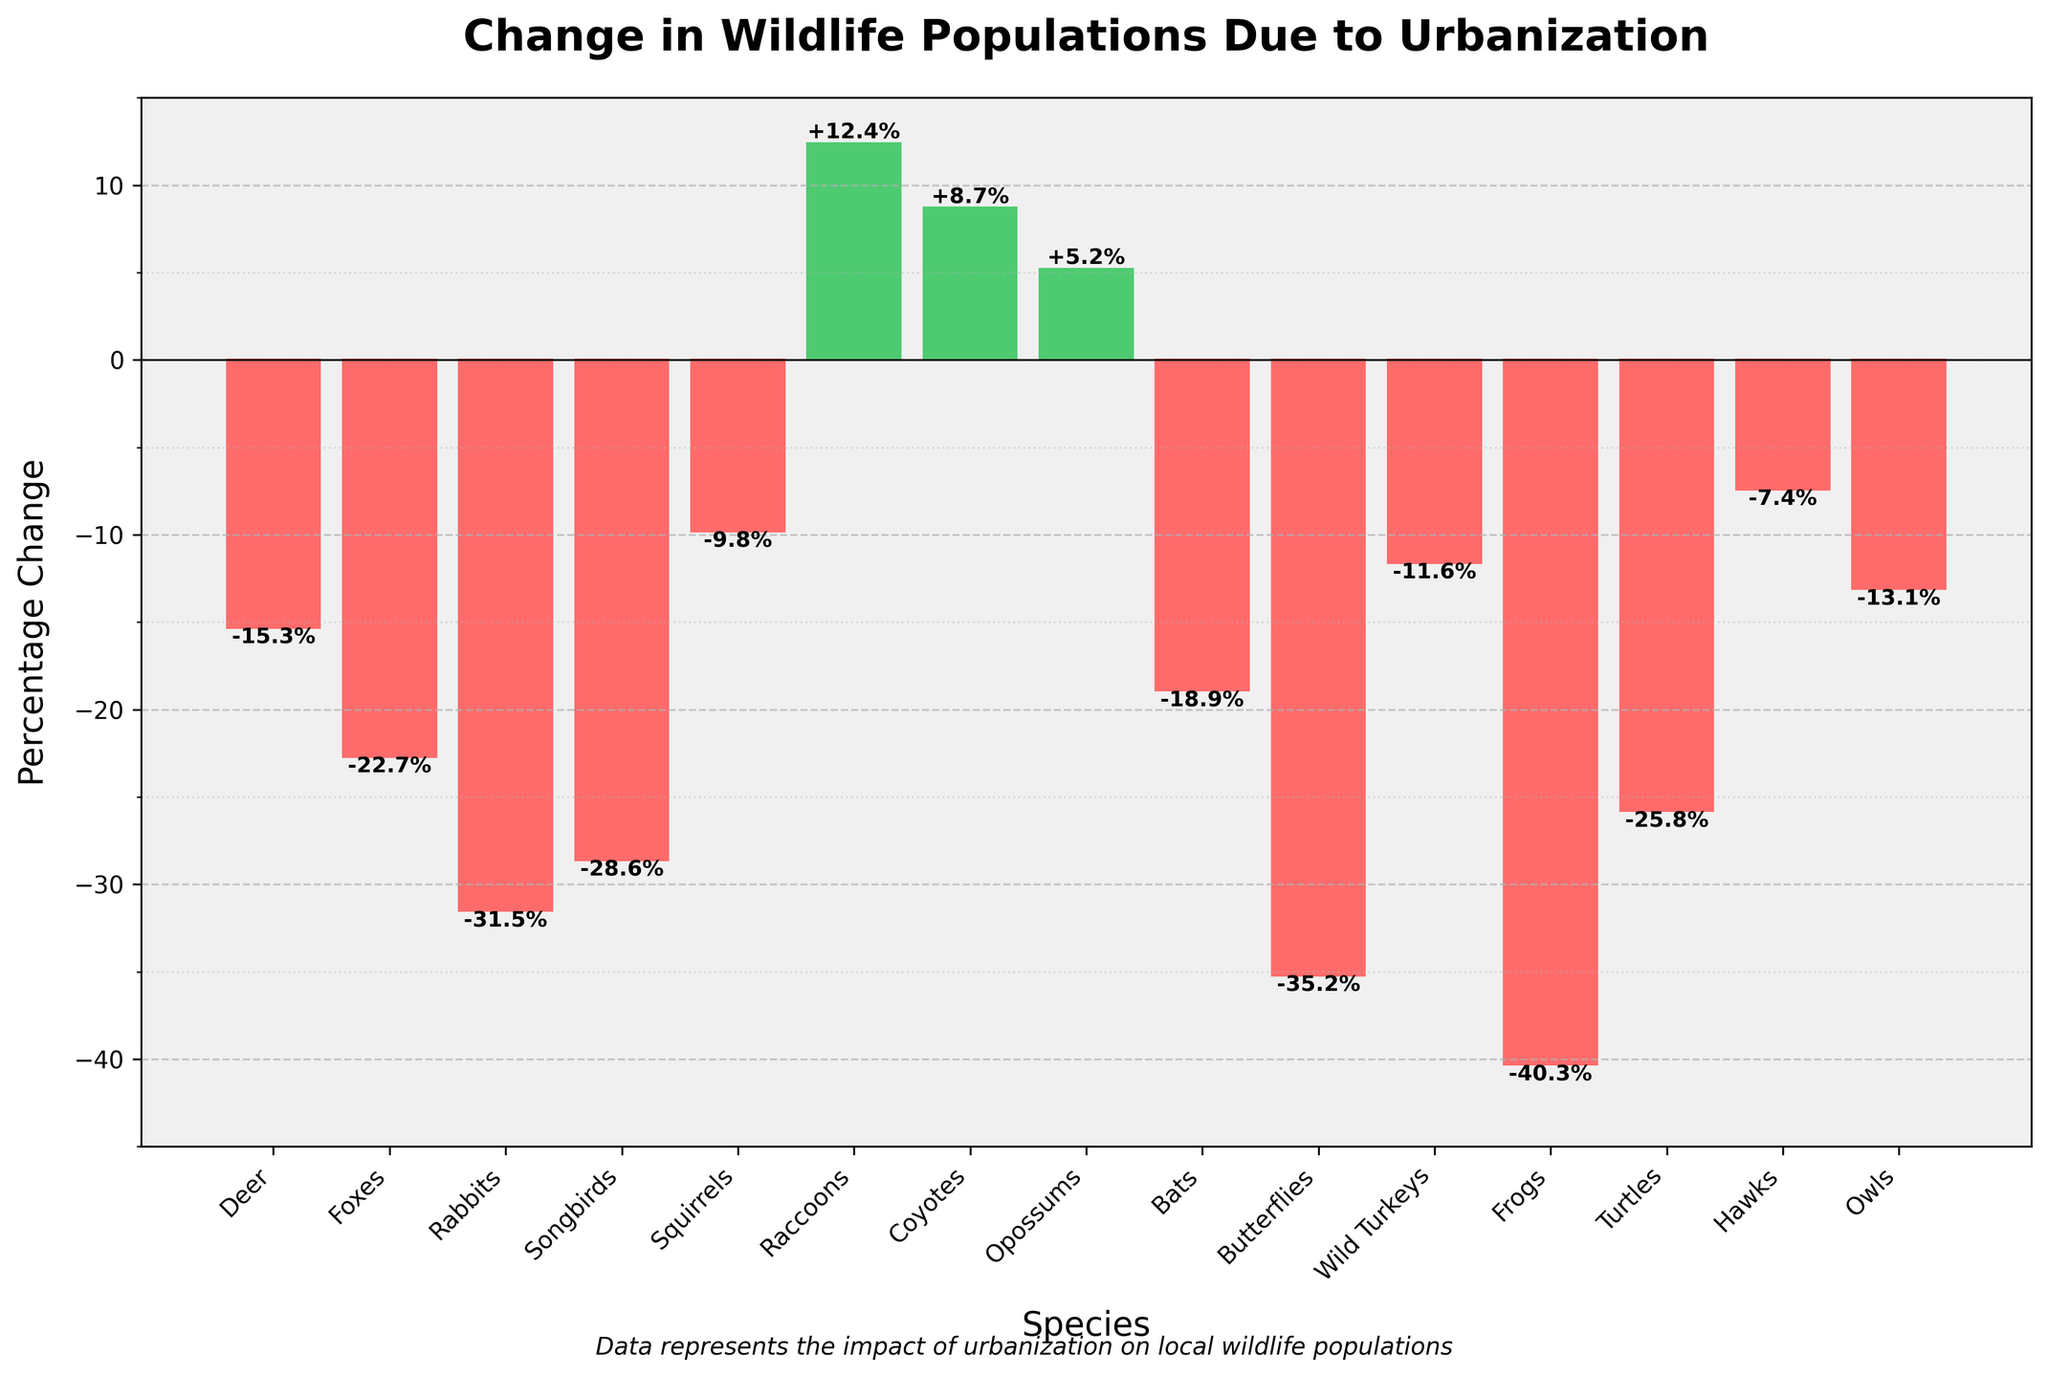Which species experienced the largest decrease in population percentage? Look at the bar chart and identify the species with the most negative value. The species with the highest negative percentage is the one with the steepest decline.
Answer: Frogs Which species saw a positive change in population percentage? Look at the bars that are above the horizontal line at y=0, those bars represent species with a positive percentage change. Identify these species from their labels at the bottom.
Answer: Raccoons, Coyotes, Opossums How much greater is the population percentage loss for Frogs compared to Songbirds? Find the percentage values for Frogs and Songbirds. Calculate the difference between these two values to determine how much greater the decline is for Frogs. Frogs: -40.3%, Songbirds: -28.6%, Difference: -40.3 - (-28.6) = -11.7%
Answer: 11.7% Which species has a percentage change closest to -15%? Look at the values associated with each bar, then identify which one is closest to -15%.
Answer: Deer What is the average percentage change for Rabbits, Songbirds, and Butterflies? Identify the percentage values for Rabbits, Songbirds, and Butterflies. Add these values together and then divide by three to get the average (% change for Rabbits: -31.5, Songbirds: -28.6, and Butterflies: -35.2). Average: (-31.5 -28.6 -35.2) / 3
Answer: -31.8 Compare the population percentage changes between nocturnal and diurnal species. How many of each group experienced a percentage change below -10%? Separate species into nocturnal (active at night) and diurnal (active during the day). Count how many in each group have percentage changes below -10%. Nocturnal: Owls, Bats, Coyotes, Raccoons; Diurnal: Hawks, Songbirds, Butterflies, Turtles, Frogs, Deer, Rabbits, Squirrels. Below -10% in Nocturnal: Bats, Owls; Below -10% in Diurnal: Songbirds, Frogs, Butterflies, Turtles, Rabbits, Deer
Answer: Nocturnal: 2, Diurnal: 6 What is the combined percentage change for Deer and Squirrels? Add the percentage changes for Deer and Squirrels together. Deer: -15.3%, Squirrels: -9.8%; Combined: -15.3 + (-9.8) = -25.1%
Answer: -25.1% Why are the bar colors for Raccoons and Coyotes different from those for Frogs and Butterflies? Observe the colors of the bars and determine the visual difference between those with positive and negative values. Bars with positive values are green, while those with negative values are red.
Answer: Positive values are green; Negative values are red Which species experienced a smaller decrease in population percentage: Hawks or Rabbits? Compare the percentage values for Hawks and Rabbits. Hawks: -7.4%, Rabbits: -31.5%; Hawks have a smaller percentage decrease.
Answer: Hawks What is the median percentage change among the given species? List all percentage changes in ascending order and find the median value. Ordered values: -40.3, -35.2, -31.5, -28.6, -25.8, -22.7, -18.9, -15.3, -13.1, -11.6, -9.8, -7.4, +5.2, +8.7, +12.4; The median value is the middle one (8th value): -15.3
Answer: -15.3 